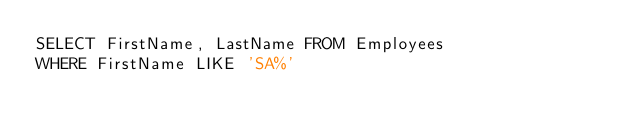<code> <loc_0><loc_0><loc_500><loc_500><_SQL_>SELECT FirstName, LastName FROM Employees
WHERE FirstName LIKE 'SA%'</code> 